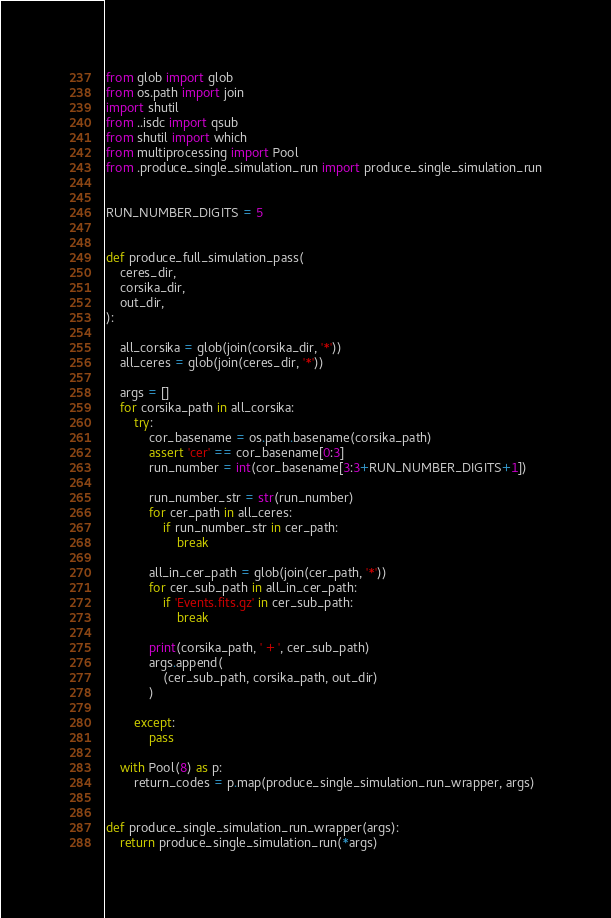Convert code to text. <code><loc_0><loc_0><loc_500><loc_500><_Python_>from glob import glob
from os.path import join
import shutil
from ..isdc import qsub
from shutil import which
from multiprocessing import Pool
from .produce_single_simulation_run import produce_single_simulation_run


RUN_NUMBER_DIGITS = 5


def produce_full_simulation_pass(
    ceres_dir,
    corsika_dir,
    out_dir,
):

    all_corsika = glob(join(corsika_dir, '*'))
    all_ceres = glob(join(ceres_dir, '*'))

    args = []
    for corsika_path in all_corsika:
        try:
            cor_basename = os.path.basename(corsika_path)
            assert 'cer' == cor_basename[0:3]
            run_number = int(cor_basename[3:3+RUN_NUMBER_DIGITS+1])

            run_number_str = str(run_number)
            for cer_path in all_ceres:
                if run_number_str in cer_path:
                    break

            all_in_cer_path = glob(join(cer_path, '*'))
            for cer_sub_path in all_in_cer_path:
                if 'Events.fits.gz' in cer_sub_path:
                    break

            print(corsika_path, ' + ', cer_sub_path)
            args.append(
                (cer_sub_path, corsika_path, out_dir)
            )

        except:
            pass

    with Pool(8) as p:
        return_codes = p.map(produce_single_simulation_run_wrapper, args)


def produce_single_simulation_run_wrapper(args):
    return produce_single_simulation_run(*args)
</code> 